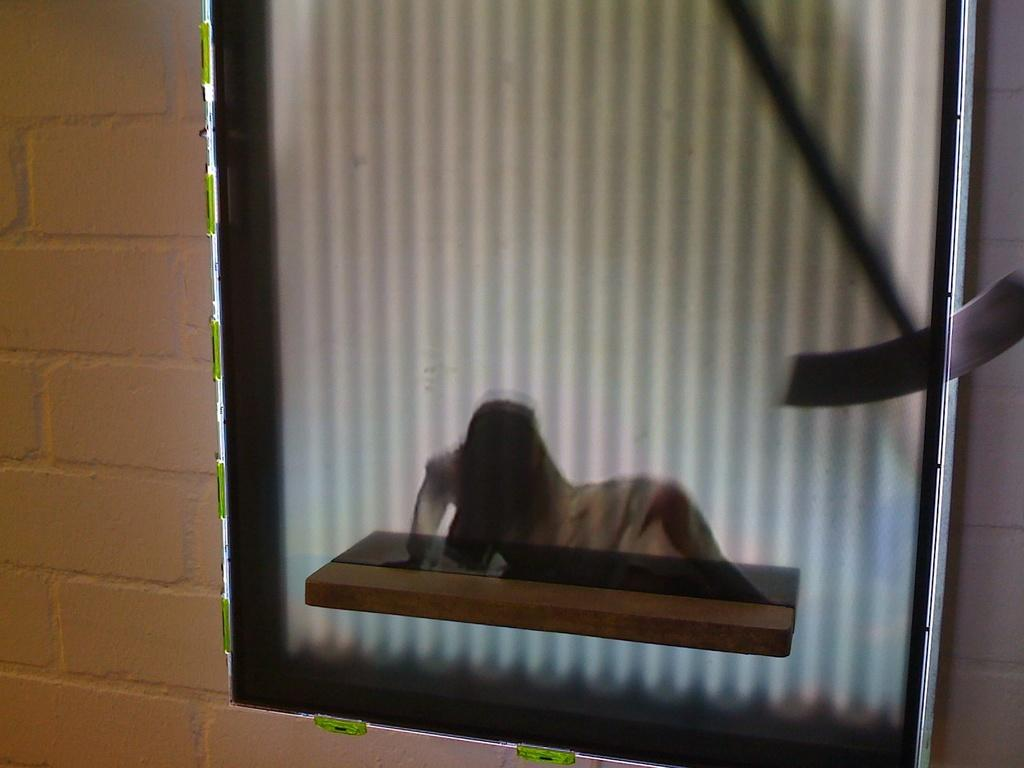What object is attached to the wall in the image? There is a mirror on the wall in the image. What can be seen on the wall in the image? The wall is visible in the image. What substance is being desired by the mirror in the image? Mirrors do not have desires or the ability to desire substances. 